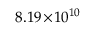Convert formula to latex. <formula><loc_0><loc_0><loc_500><loc_500>8 . 1 9 \, \times \, 1 0 ^ { 1 0 }</formula> 